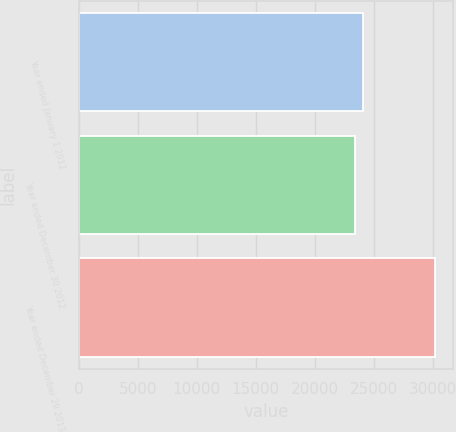Convert chart. <chart><loc_0><loc_0><loc_500><loc_500><bar_chart><fcel>Year ended January 1 2012<fcel>Year ended December 30 2012<fcel>Year ended December 29 2013<nl><fcel>24046.8<fcel>23362<fcel>30210<nl></chart> 